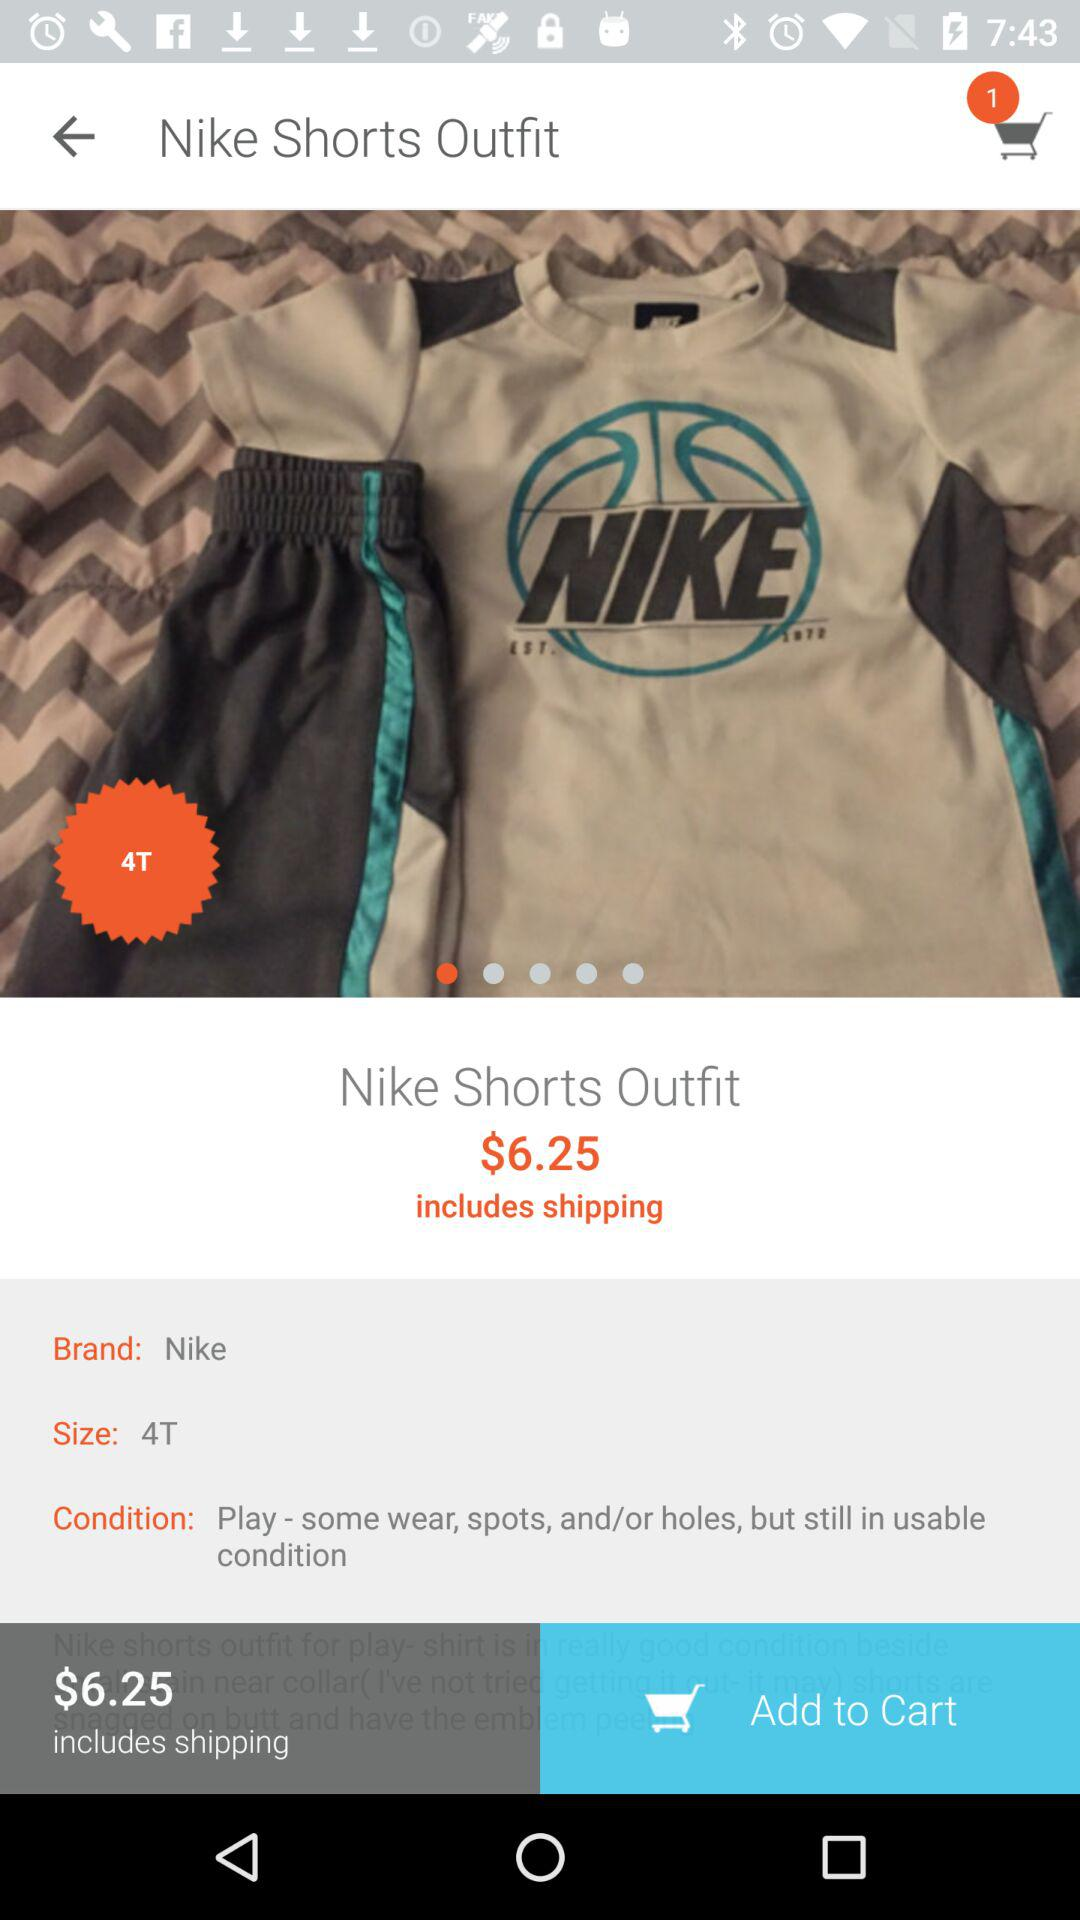What is the price of the Nike Shorts Outfit?
Answer the question using a single word or phrase. $6.25 